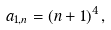Convert formula to latex. <formula><loc_0><loc_0><loc_500><loc_500>a _ { 1 , n } = ( n + 1 ) ^ { 4 } \, ,</formula> 